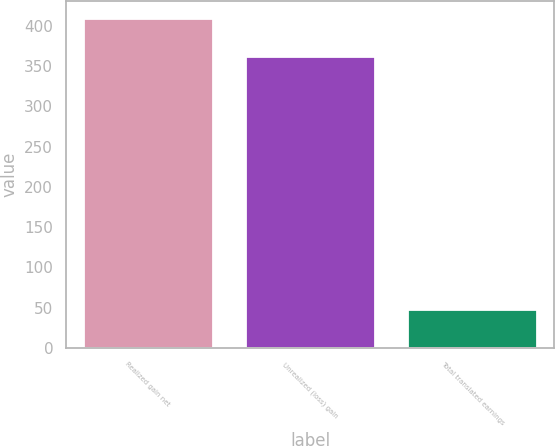<chart> <loc_0><loc_0><loc_500><loc_500><bar_chart><fcel>Realized gain net<fcel>Unrealized (loss) gain<fcel>Total translated earnings<nl><fcel>410<fcel>362<fcel>48<nl></chart> 